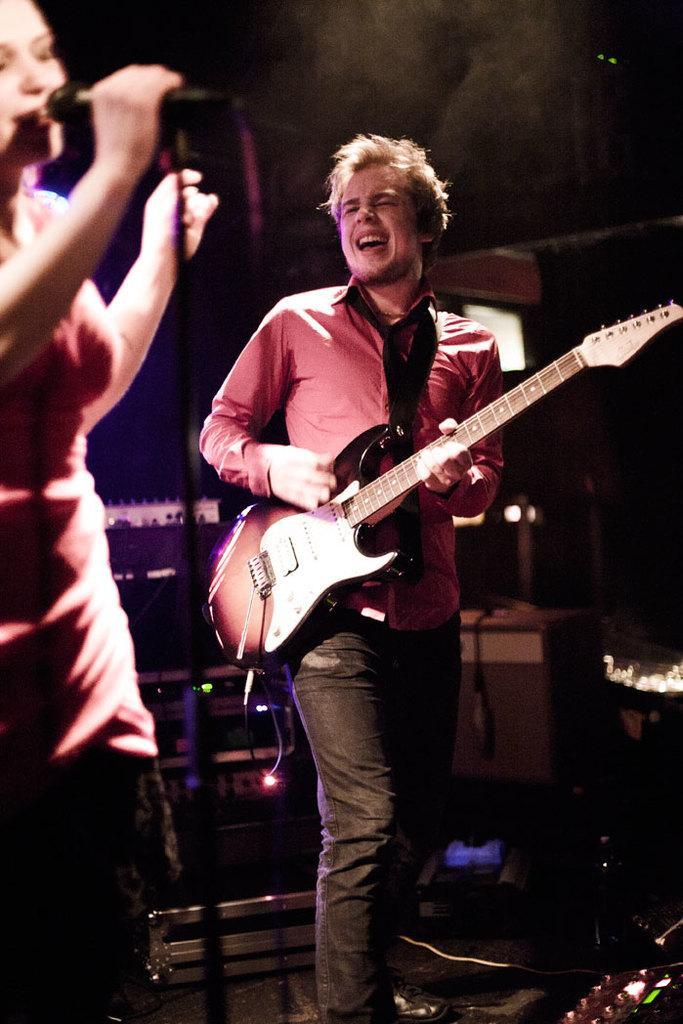Describe this image in one or two sentences. This picture shows a man Standing and playing a guitar and singing and we see a woman standing and holding a microphone in her hands and singing 